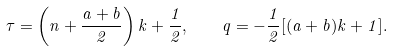<formula> <loc_0><loc_0><loc_500><loc_500>\tau = \left ( n + \frac { a + b } { 2 } \right ) k + \frac { 1 } { 2 } , \quad q = - \frac { 1 } { 2 } [ ( a + b ) k + 1 ] .</formula> 